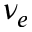Convert formula to latex. <formula><loc_0><loc_0><loc_500><loc_500>\nu _ { e }</formula> 